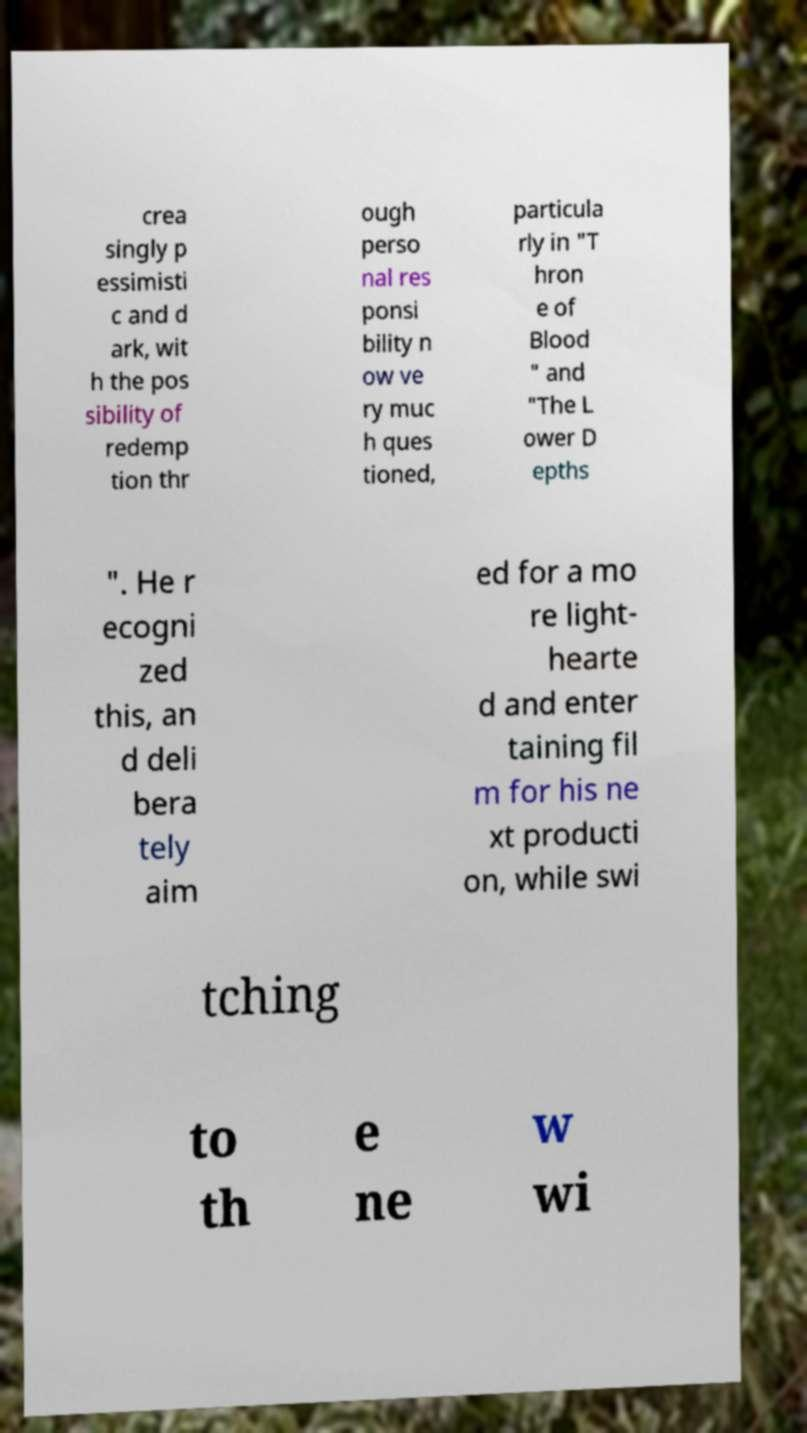Please read and relay the text visible in this image. What does it say? crea singly p essimisti c and d ark, wit h the pos sibility of redemp tion thr ough perso nal res ponsi bility n ow ve ry muc h ques tioned, particula rly in "T hron e of Blood " and "The L ower D epths ". He r ecogni zed this, an d deli bera tely aim ed for a mo re light- hearte d and enter taining fil m for his ne xt producti on, while swi tching to th e ne w wi 